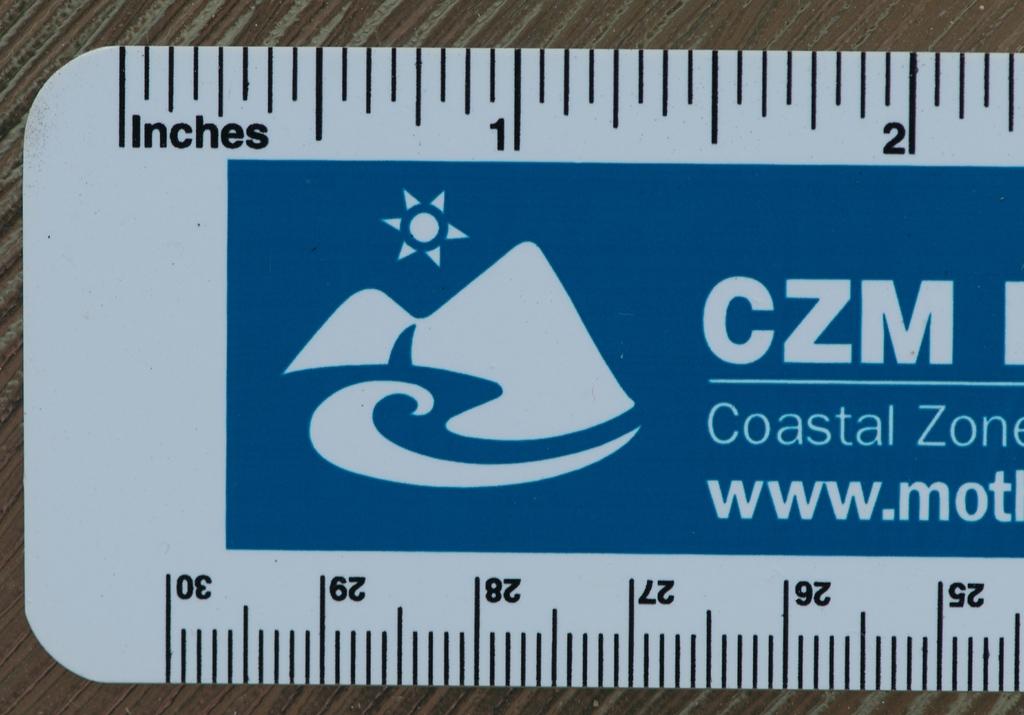Which unit of measurement is visible on the ruler?
Give a very brief answer. Inches. What is the unit of measurement at the top?
Your answer should be very brief. Inches. 